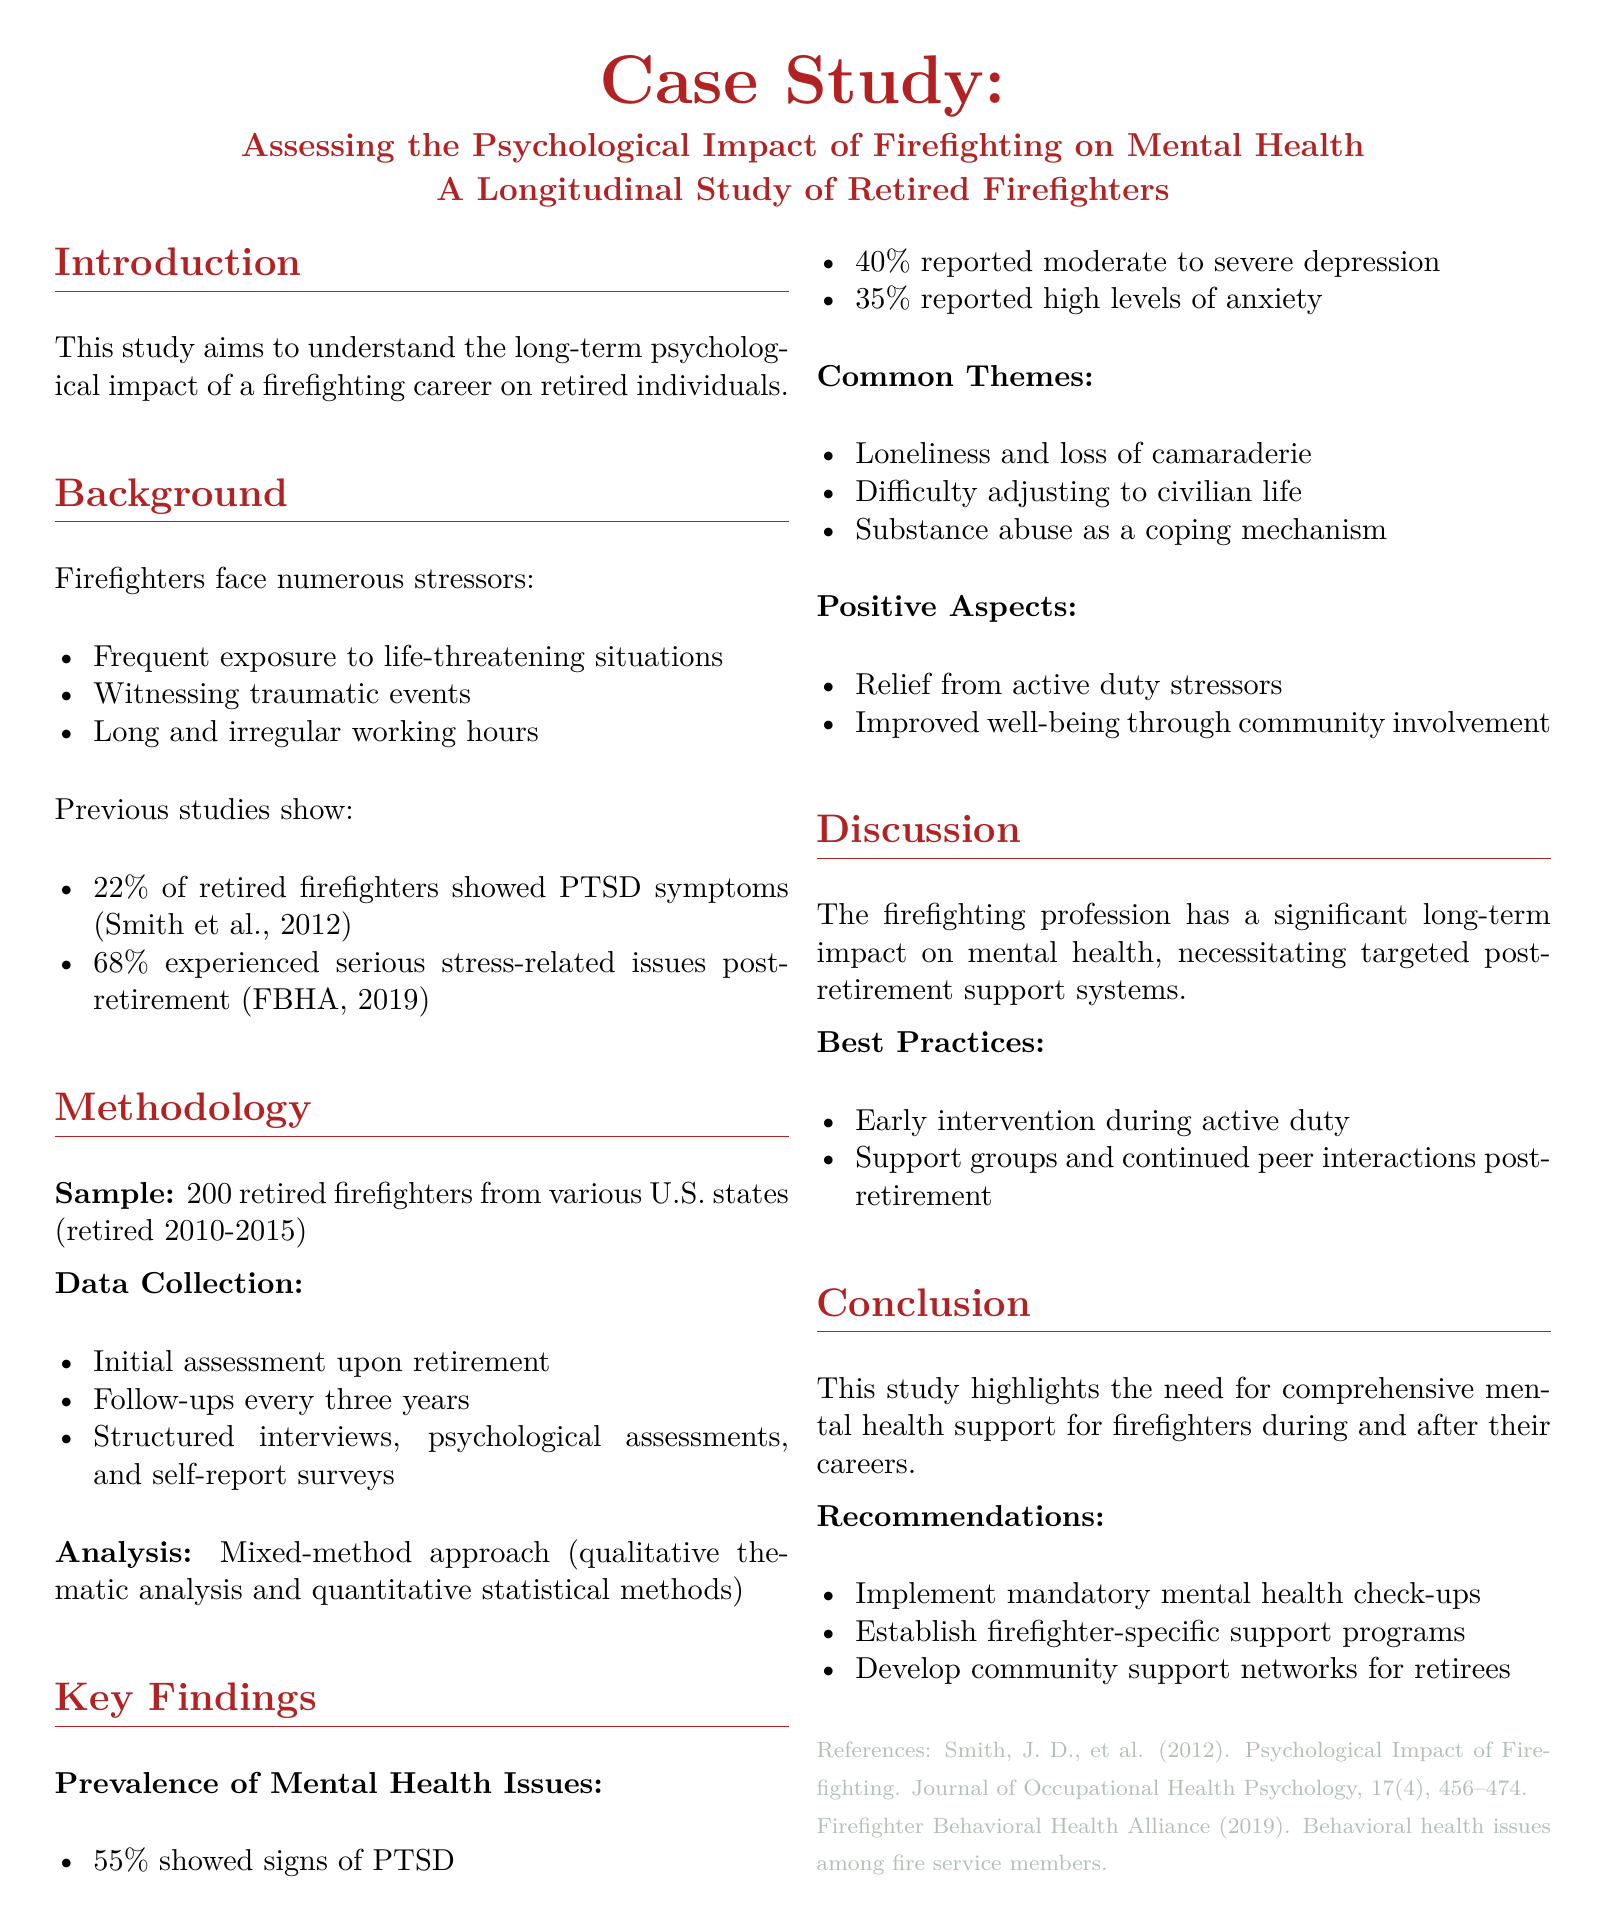What was the sample size of the study? The sample size is stated clearly in the methodology section, which lists 200 retired firefighters.
Answer: 200 What percentage of retired firefighters showed signs of PTSD? The key findings section provides this information, indicating 55%.
Answer: 55% What common theme was identified related to adjusting to civilian life? The document highlights "Difficulty adjusting to civilian life" as one of the common themes in the findings.
Answer: Difficulty adjusting to civilian life What was one of the positive aspects found in the study? The key findings section mentions "Relief from active duty stressors" as a positive aspect.
Answer: Relief from active duty stressors What year range did the firefighters retire? The methodology specifies that the firefighters retired between 2010 and 2015.
Answer: 2010-2015 What is one of the best practices recommended in the study? The document lists "Early intervention during active duty" as a recommended best practice.
Answer: Early intervention during active duty What percentage of retired firefighters reported moderate to severe depression? The key findings section specifically states that 40% reported moderate to severe depression.
Answer: 40% What organization's study is referenced for PTSD symptoms? The document refers to a study by Smith et al., published in 2012.
Answer: Smith et al., 2012 